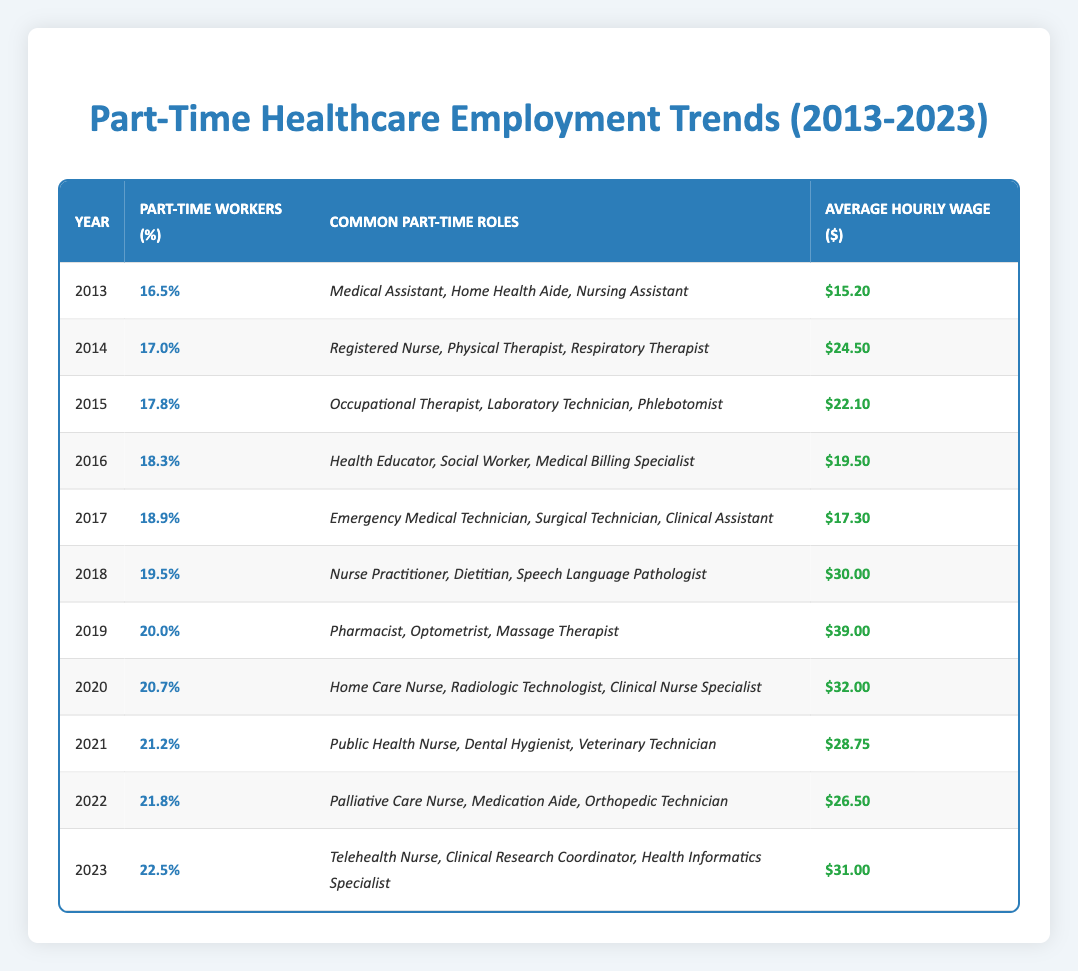What was the percentage of part-time healthcare workers in 2019? The table shows that in 2019, the percentage of part-time healthcare workers was 20.0%, which is directly referenced in the corresponding row.
Answer: 20.0% Which year had the highest average hourly wage for part-time healthcare roles? In examining the table, the year with the highest average hourly wage is 2019 with an average wage of $39.00, as indicated in that row.
Answer: 2019 What is the average percentage of part-time healthcare workers from 2013 to 2023? To find the average, we take the sum of the percentages from all years (16.5 + 17.0 + 17.8 + 18.3 + 18.9 + 19.5 + 20.0 + 20.7 + 21.2 + 21.8 + 22.5) =  218.8 and divide by the number of years (11): 218.8 / 11 = 19.08.
Answer: 19.08% In which year did the percentage of part-time healthcare workers cross the 20% mark? By reviewing the table, the percentage first crosses 20% in 2019, as seen where it is listed as 20.0% in that year and subsequent years remain above this threshold.
Answer: 2019 Did the average hourly wage for part-time healthcare roles increase every year from 2013 to 2023? By checking the wages listed for each year, it can be seen that there are fluctuations; for instance, the wage in 2014 is lower than in 2013 and there are decreases noted up to 2018. Thus, not every year shows an increase.
Answer: No What is the average hourly wage for part-time roles in 2022 compared to 2023? Comparing the values from 2022 ($26.50) and 2023 ($31.00), the average hourly wage increased. The difference is calculated as follows: 31.00 - 26.50 = 4.50, indicating that it rose by $4.50 from 2022 to 2023.
Answer: Increased by $4.50 Which common part-time role earned the highest average hourly wage in 2018? The table shows the common roles listed for 2018 and the average hourly wage is $30.00. Among the roles like Nurse Practitioner, Dietitian, and Speech Language Pathologist, the highest average wage matches the overall hourly wage for the year.
Answer: Nurse Practitioner Which year saw the largest increase in the percentage of part-time healthcare workers from the previous year? By examining the percentage changes year-over-year: 2016 to 2017 has a change of 0.6% (18.9 - 18.3), whereas from 2021 to 2022, it is 0.6% (21.8 - 21.2), but from 2022 to 2023, the change is 0.7% (22.5 - 21.8). Therefore, the largest increase was from 2022 to 2023.
Answer: 2022 to 2023 What are the most common part-time roles listed for the year 2020? According to the table data for the year 2020, the part-time roles were Home Care Nurse, Radiologic Technologist, and Clinical Nurse Specialist, as outlined in the respective row.
Answer: Home Care Nurse, Radiologic Technologist, Clinical Nurse Specialist 